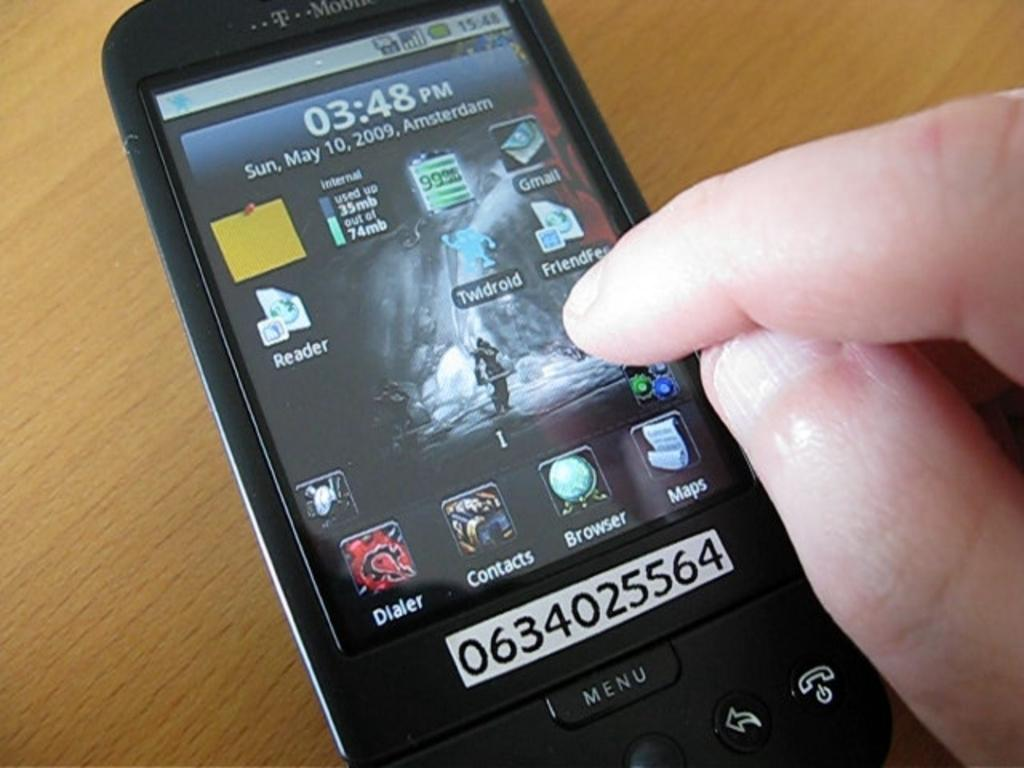<image>
Summarize the visual content of the image. a t mobile cell phone with serial number 0634025564 